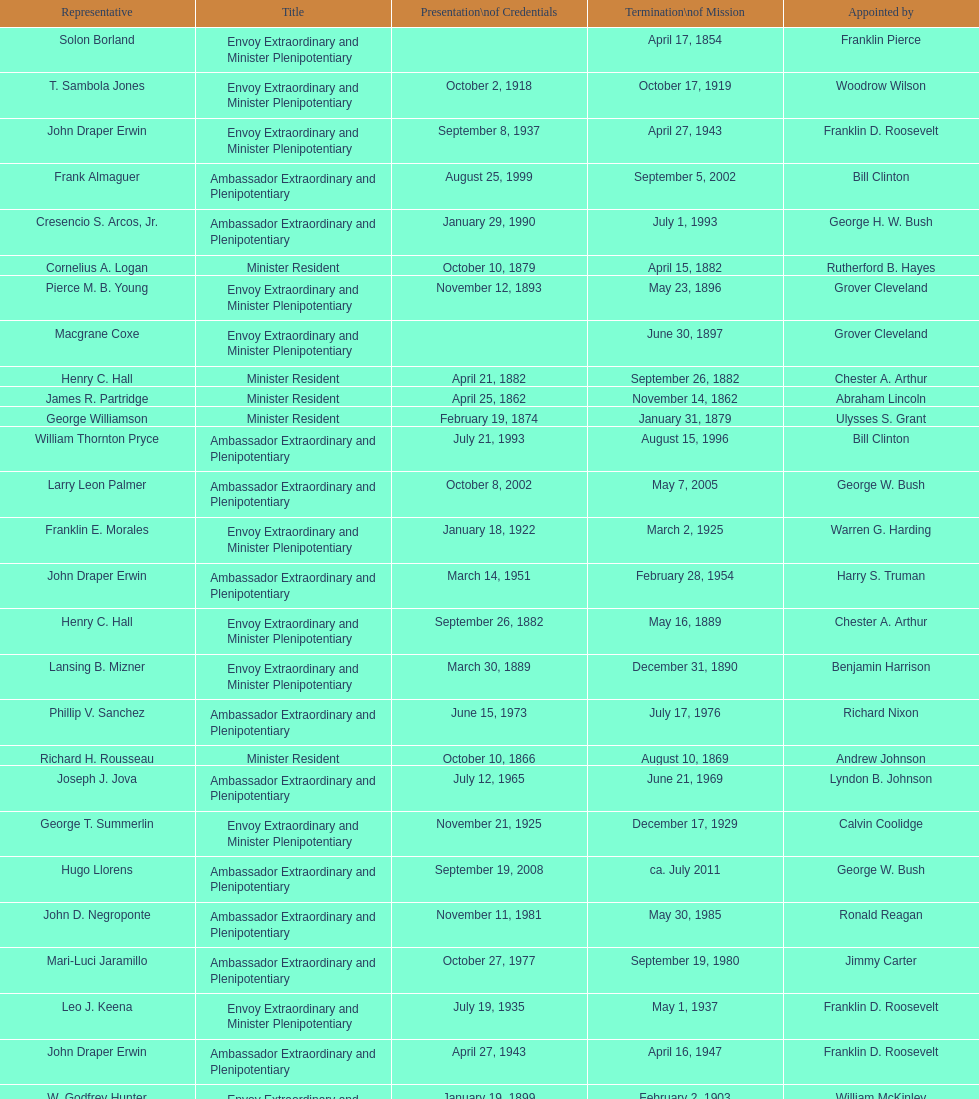Which reps were only appointed by franklin pierce? Solon Borland. 